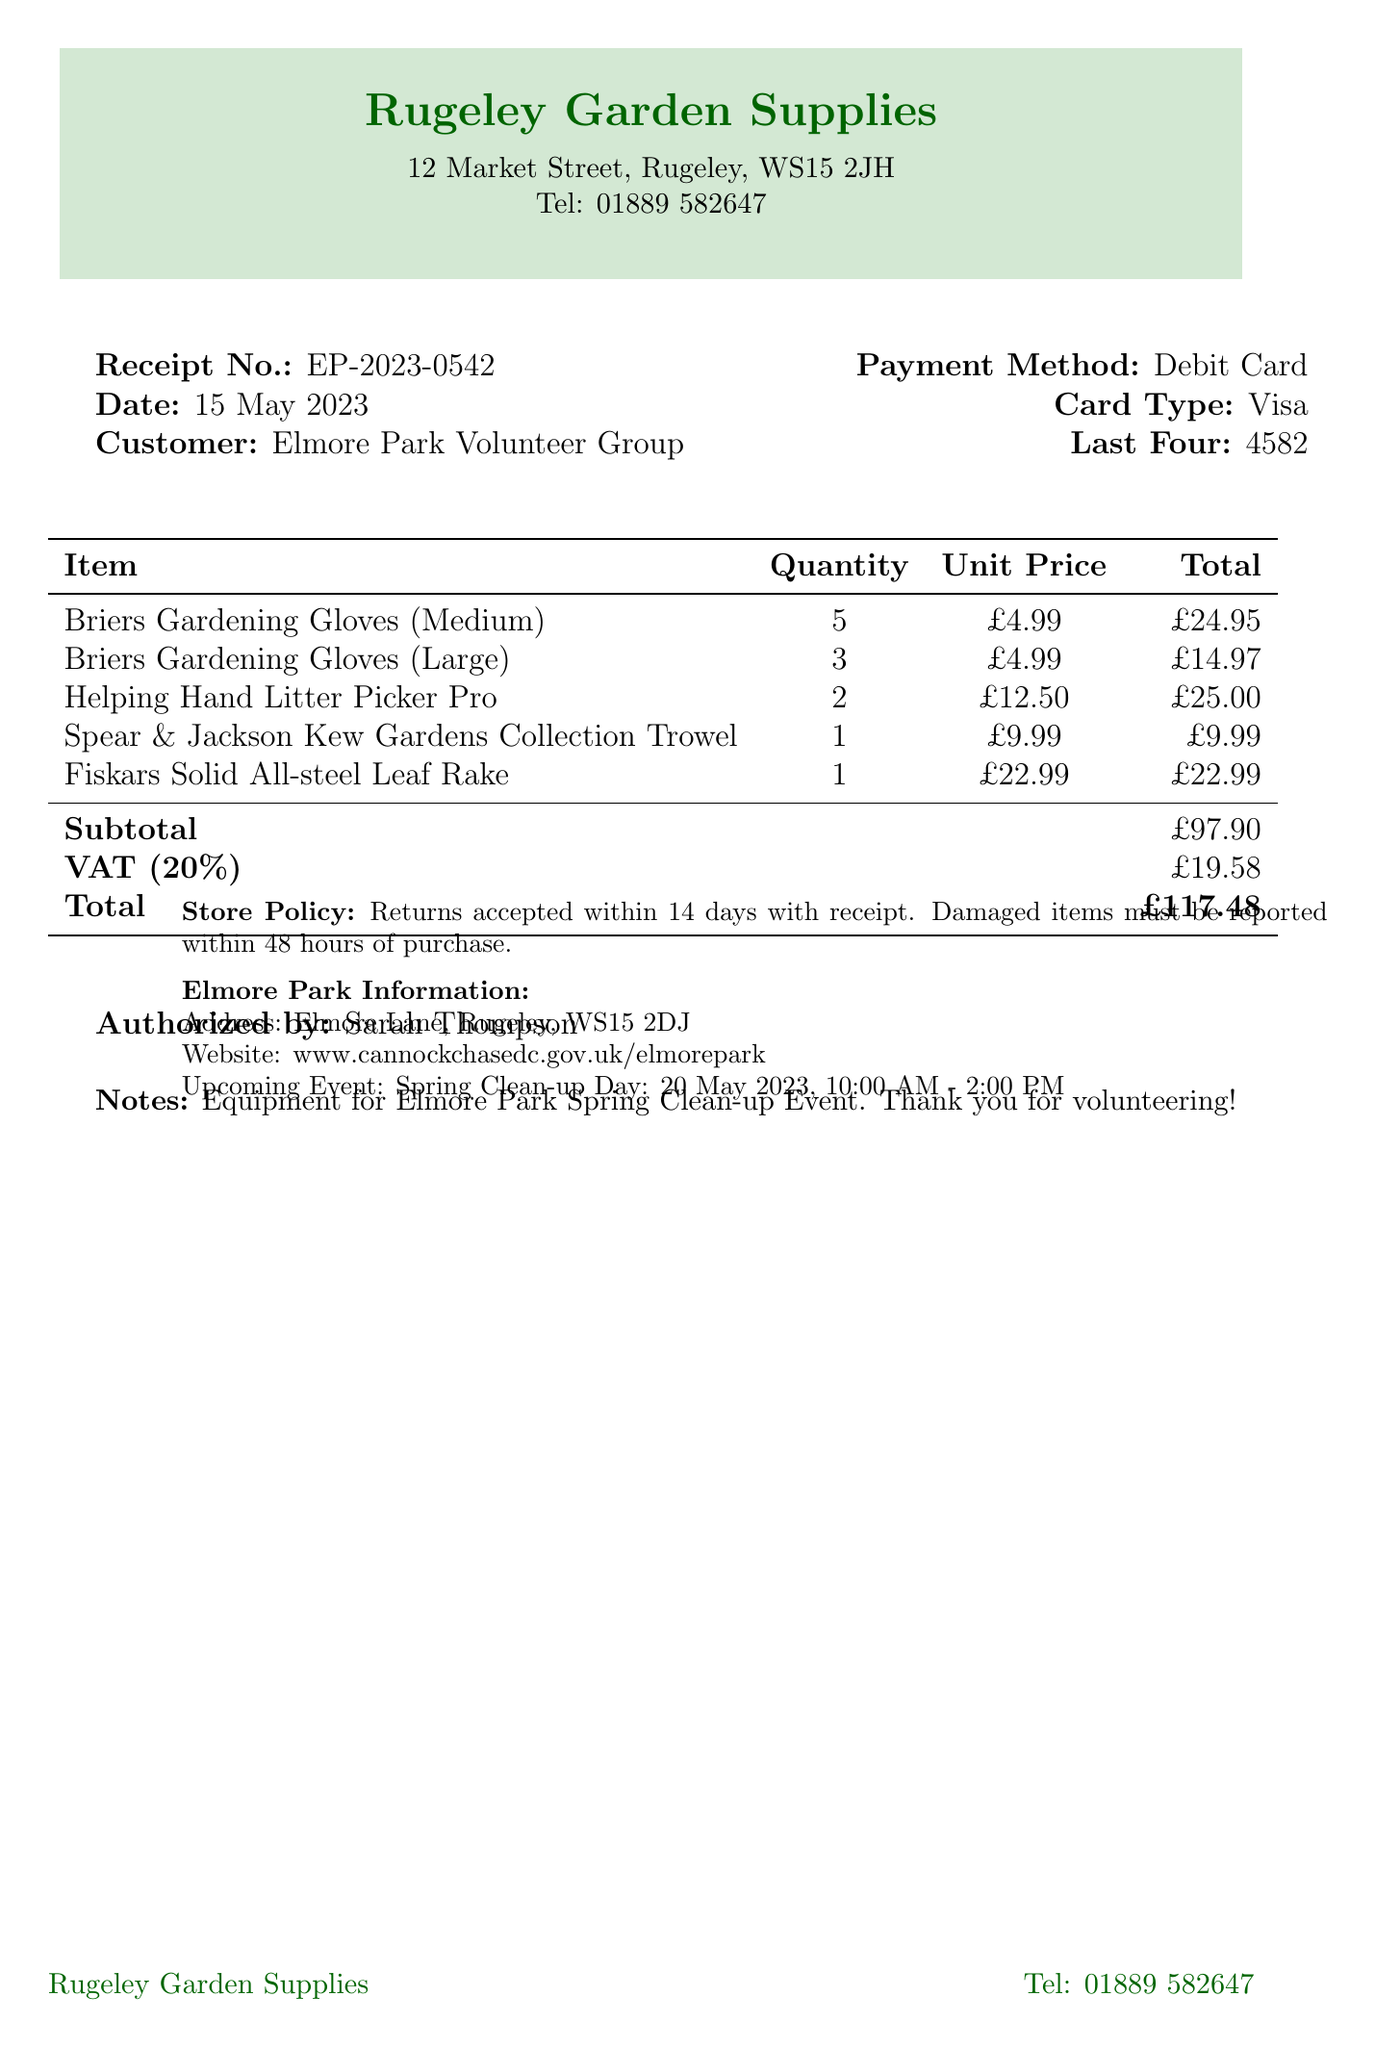What is the receipt number? The receipt number is listed prominently in the document for easy reference.
Answer: EP-2023-0542 Who is the authorized person for the purchase? The authorized person is noted at the bottom of the receipt, indicating who approved the transaction.
Answer: Sarah Thompson What is the total amount spent? The total amount is calculated by adding the subtotal and VAT, making it the final cost of the purchase.
Answer: £117.48 How many Briers Gardening Gloves (Medium) were purchased? The quantity of specific items is detailed in the itemized list on the receipt.
Answer: 5 What is the address of Elmore Park? The address is provided at the bottom of the receipt under park information.
Answer: Elmore Lane, Rugeley, WS15 2DJ What was the payment method used? The payment method is mentioned clearly in the receipt's transaction details.
Answer: Debit Card When is the upcoming Elmore Park event? The upcoming event is specified in the park information section of the receipt.
Answer: Spring Clean-up Day: 20 May 2023, 10:00 AM - 2:00 PM How many Helping Hand Litter Pickers were purchased? This information can be found in the list of purchased items.
Answer: 2 What is the store policy regarding returns? The store policy is stated on the receipt to inform customers about return conditions.
Answer: Returns accepted within 14 days with receipt 